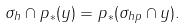<formula> <loc_0><loc_0><loc_500><loc_500>\sigma _ { h } \cap p _ { * } ( y ) = p _ { * } ( \sigma _ { h p } \cap y ) .</formula> 